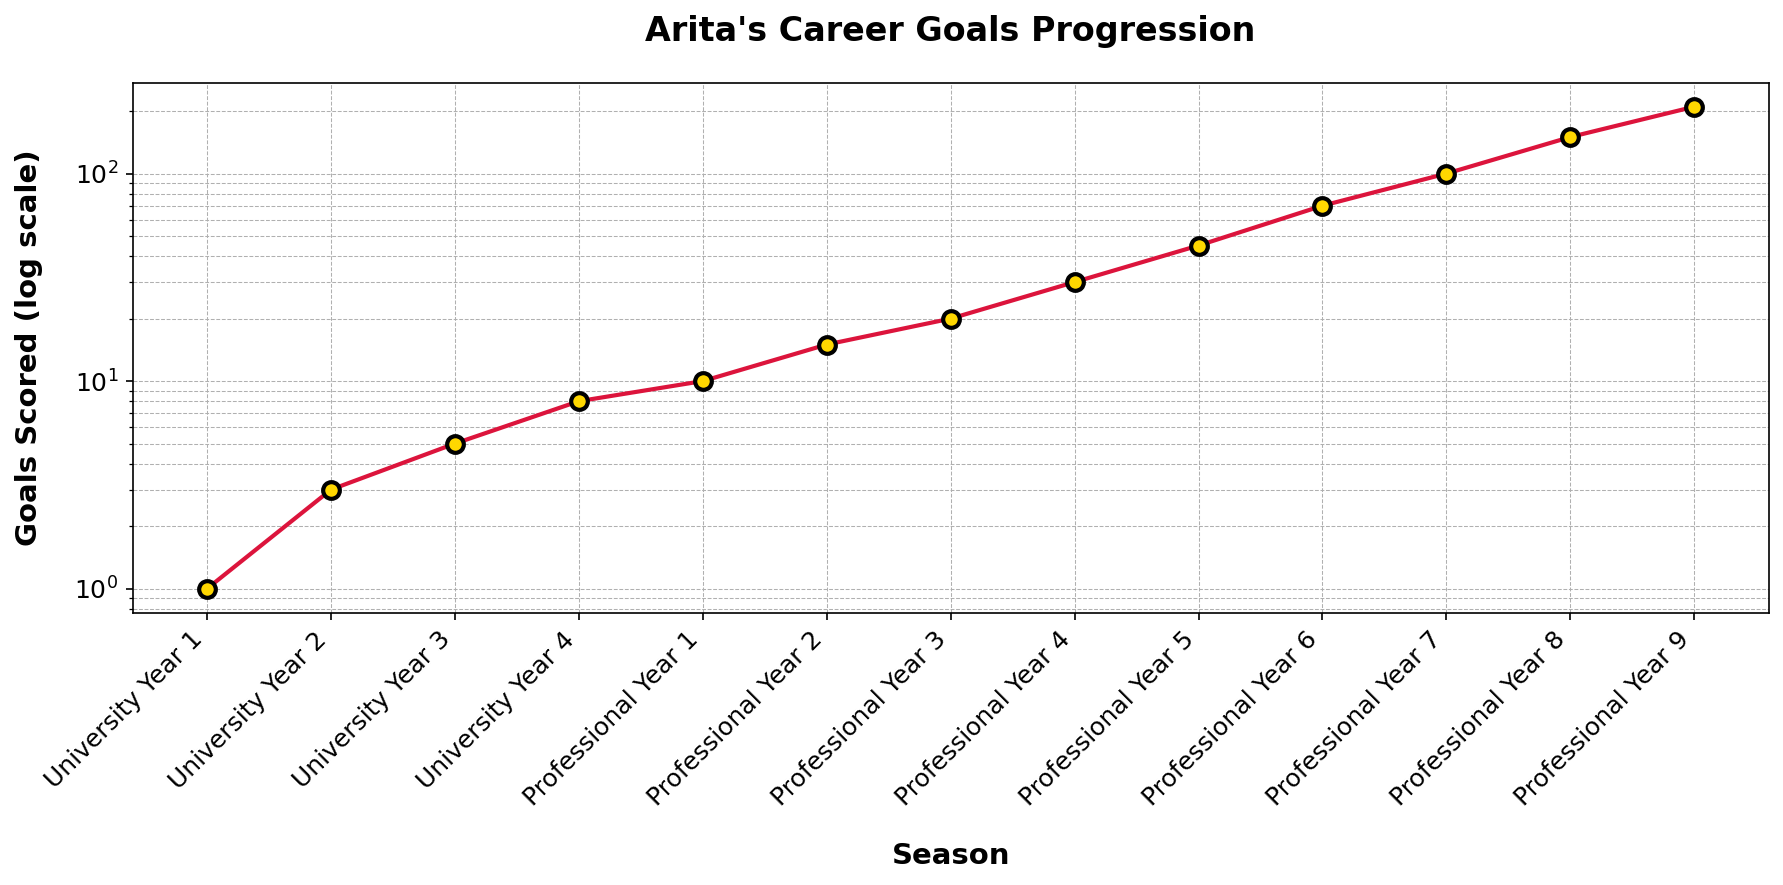How many goals did Arita score during his university years? To find the total goals scored during university years, sum the goals from University Year 1 through University Year 4: 1 + 3 + 5 + 8 = 17.
Answer: 17 In which season did Arita first exceed 20 goals in a single year? Look at the y-axis values and find the first season where the goals scored surpass 20. This occurs in Professional Year 3.
Answer: Professional Year 3 By how many goals did Arita's performance improve from Professional Year 5 to Professional Year 7? Calculate the difference in goals scored between Professional Year 7 and Professional Year 5: 100 - 45 = 55.
Answer: 55 What is the ratio of goals scored in Professional Year 9 to University Year 1? First find the goals scored in these two years: Professional Year 9 = 210, University Year 1 = 1. Then calculate the ratio: 210 / 1 = 210.
Answer: 210 During which professional year did Arita experience the largest increase in goals scored compared to the previous year? Find the differences between each consecutive professional year and identify the largest increase. Observe the log-scale to determine that the biggest jump is between Professional Year 8 (150 goals) and Professional Year 9 (210 goals) with an increase of 60 goals.
Answer: Professional Year 9 How many seasons did it take for Arita to go from scoring 10 goals a season to scoring over 100 goals a season? Identify the seasons where Arita scored 10 goals and 100 goals. He scored 10 goals in Professional Year 1 and 100 goals in Professional Year 7; the difference in seasons is 7 - 1 = 6.
Answer: 6 By what factor did Arita's goals increase from University Year 1 to Professional Year 9? First identify the goals scored in University Year 1 (1 goal) and Professional Year 9 (210 goals). Then calculate the factor of increase: 210 / 1 = 210.
Answer: 210 Compare the goal progression rate during Arita's university years vs. professional years by looking at his total goals scored during each period. Which period had a faster rate of increase? Calculate the total goals in both periods. University total: 1 + 3 + 5 + 8 = 17, Professional total: 10 + 15 + 20 + 30 + 45 + 70 + 100 + 150 + 210 = 650. Note that he played 4 university seasons and 9 professional seasons. To understand the rate increase, we divide by the number of seasons: University rate = 17/4 = 4.25, Professional rate = 650/9 ≈ 72.22.
Answer: Professional years What is the average number of goals scored per season by Arita during his professional career? First, find the total goals scored during his professional career (650 goals across 9 seasons). Then calculate the average: 650 / 9 ≈ 72.22.
Answer: 72.22 